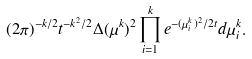Convert formula to latex. <formula><loc_0><loc_0><loc_500><loc_500>( 2 \pi ) ^ { - k / 2 } t ^ { - k ^ { 2 } / 2 } \Delta ( \mu ^ { k } ) ^ { 2 } \prod _ { i = 1 } ^ { k } e ^ { - ( \mu ^ { k } _ { i } ) ^ { 2 } / 2 t } d \mu ^ { k } _ { i } .</formula> 